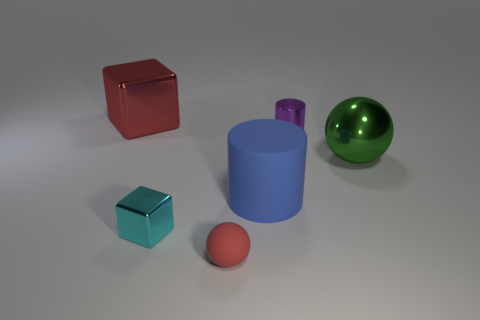What could be the possible sizes of these objects if we assume the red cube is 30 cm on each side? Using the red cube as a reference point, the large green sphere may be around 45 cm in diameter, while the blue cylinder and small cyan cube could be approximately 15 cm in height and 10 cm on each side respectively. 